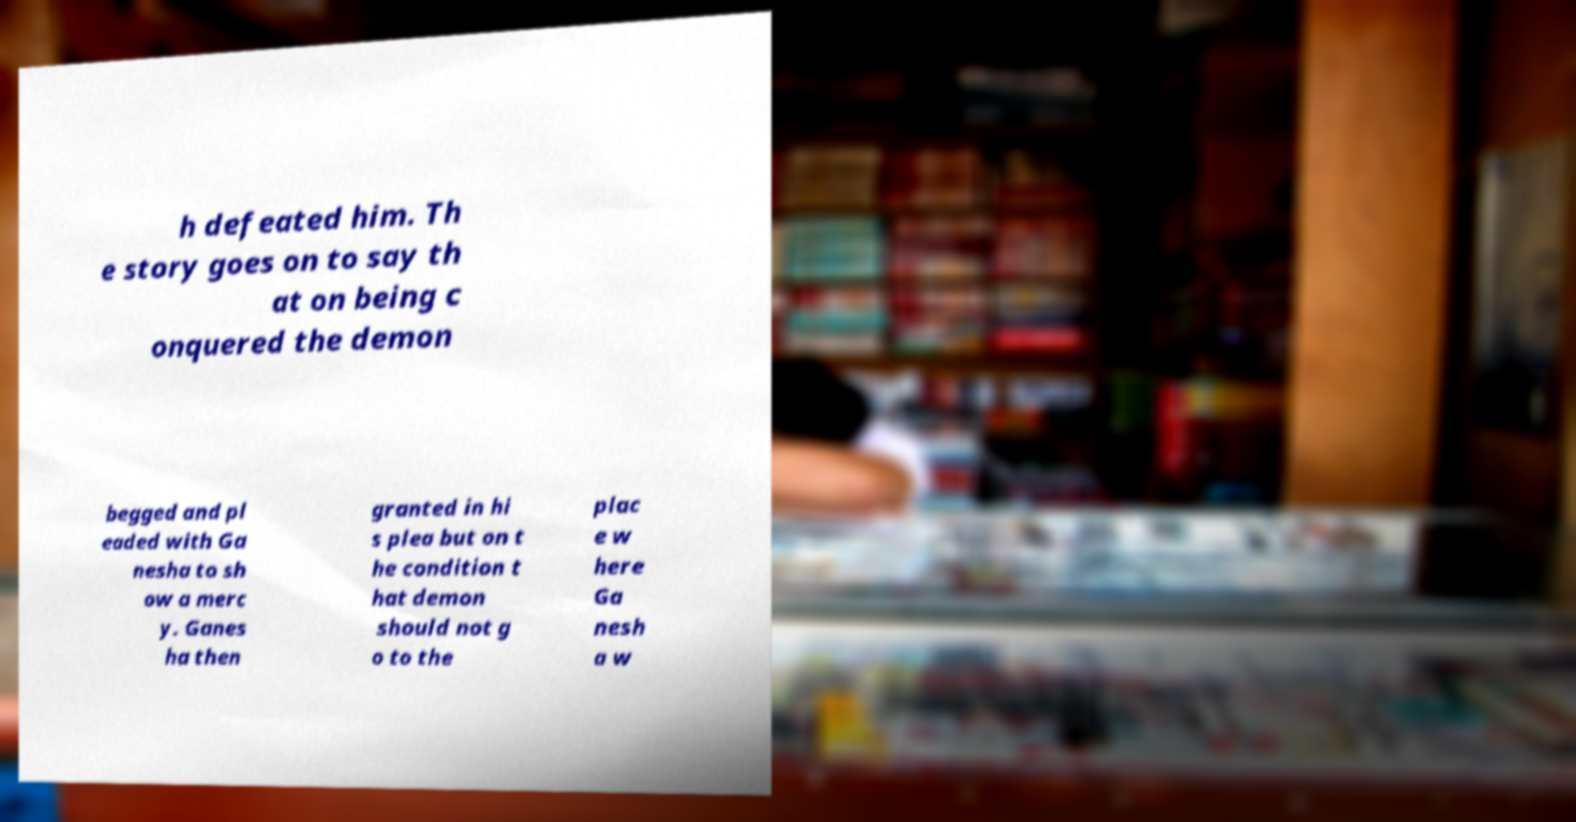Could you assist in decoding the text presented in this image and type it out clearly? h defeated him. Th e story goes on to say th at on being c onquered the demon begged and pl eaded with Ga nesha to sh ow a merc y. Ganes ha then granted in hi s plea but on t he condition t hat demon should not g o to the plac e w here Ga nesh a w 